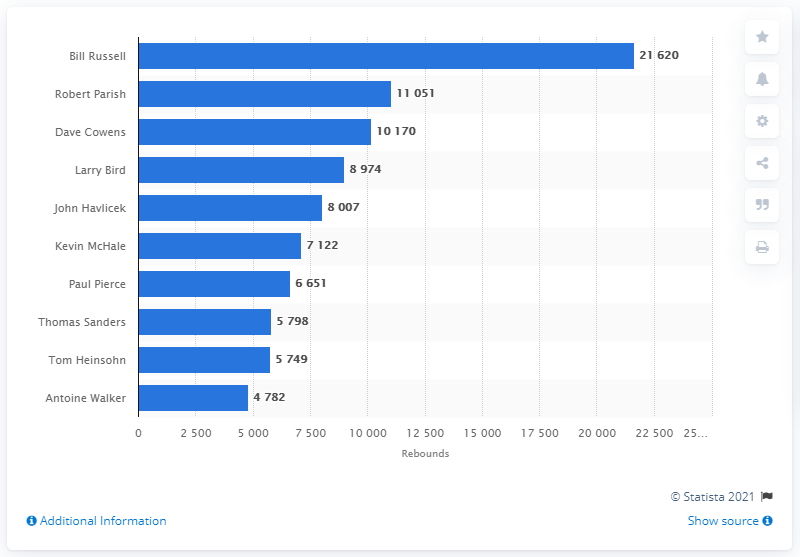Specify some key components in this picture. Bill Russell is the career rebounds leader of the Boston Celtics. 